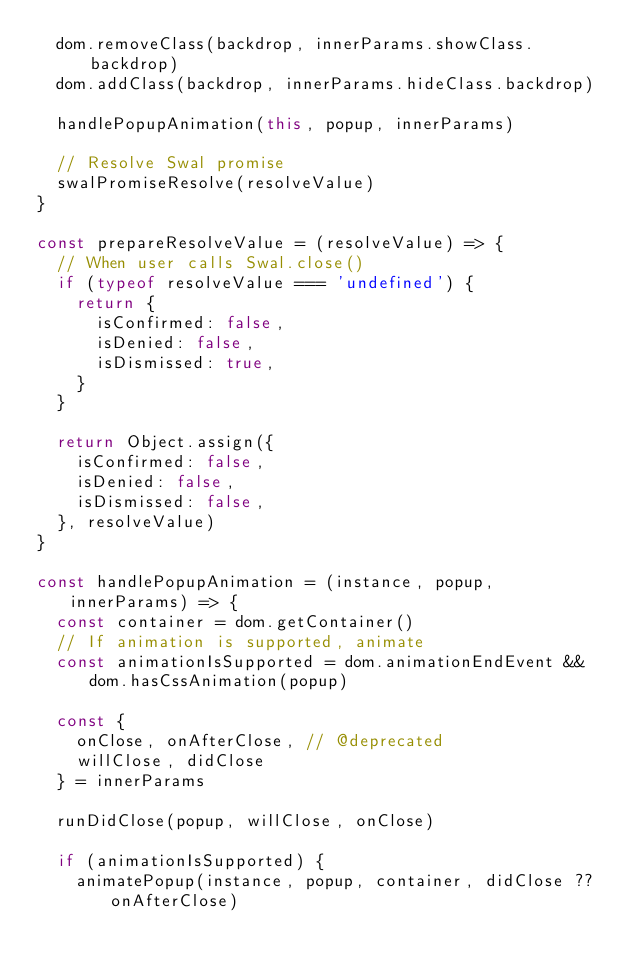<code> <loc_0><loc_0><loc_500><loc_500><_JavaScript_>  dom.removeClass(backdrop, innerParams.showClass.backdrop)
  dom.addClass(backdrop, innerParams.hideClass.backdrop)

  handlePopupAnimation(this, popup, innerParams)

  // Resolve Swal promise
  swalPromiseResolve(resolveValue)
}

const prepareResolveValue = (resolveValue) => {
  // When user calls Swal.close()
  if (typeof resolveValue === 'undefined') {
    return {
      isConfirmed: false,
      isDenied: false,
      isDismissed: true,
    }
  }

  return Object.assign({
    isConfirmed: false,
    isDenied: false,
    isDismissed: false,
  }, resolveValue)
}

const handlePopupAnimation = (instance, popup, innerParams) => {
  const container = dom.getContainer()
  // If animation is supported, animate
  const animationIsSupported = dom.animationEndEvent && dom.hasCssAnimation(popup)

  const {
    onClose, onAfterClose, // @deprecated
    willClose, didClose
  } = innerParams

  runDidClose(popup, willClose, onClose)

  if (animationIsSupported) {
    animatePopup(instance, popup, container, didClose ?? onAfterClose)</code> 